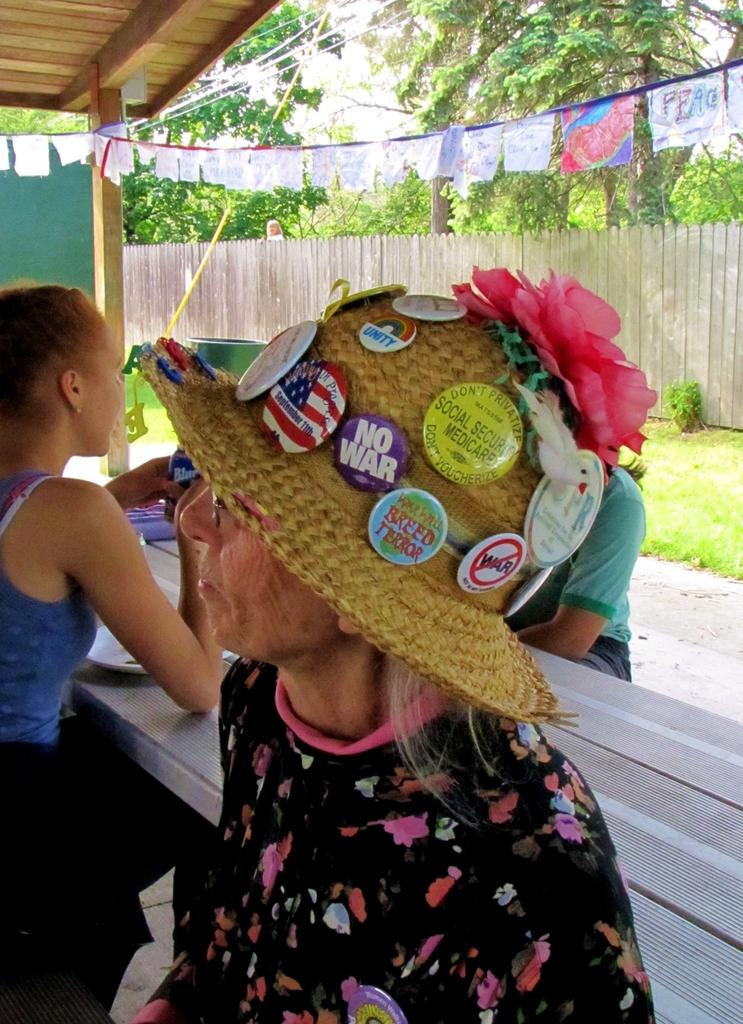What are the people in the image doing? The people in the image are sitting on chairs. What is present on the ground in the image? There is a table in the image. What is above the people in the image? There is a roof visible in the image. What type of wall can be seen in the background of the image? There is a wooden wall in the background of the image. What type of natural environment is visible in the background of the image? There is grassland and trees in the background of the image. Can you see the paint drying on the chairs in the image? There is no mention of paint on the chairs in the image, so it cannot be determined if the paint is drying. 